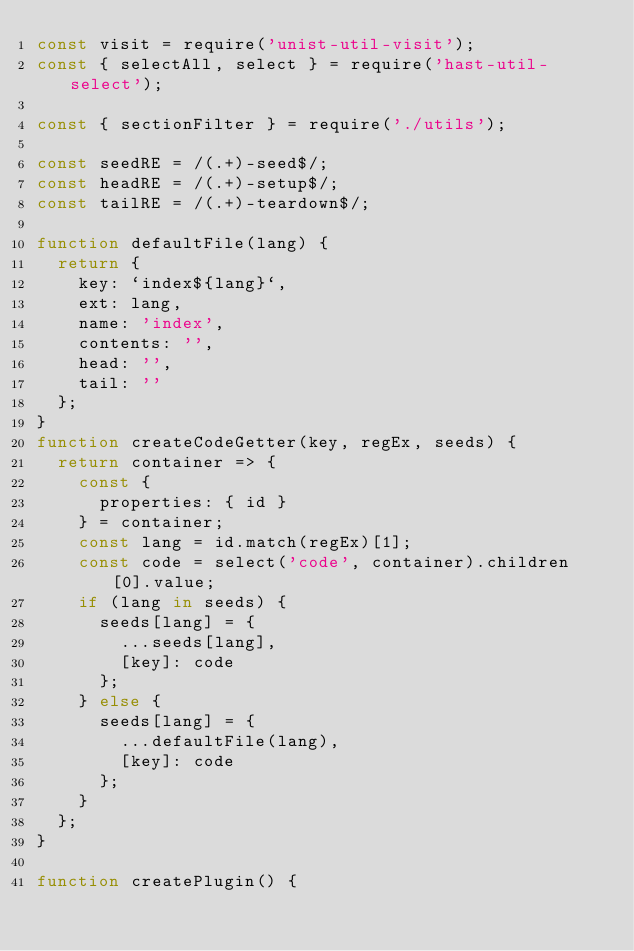<code> <loc_0><loc_0><loc_500><loc_500><_JavaScript_>const visit = require('unist-util-visit');
const { selectAll, select } = require('hast-util-select');

const { sectionFilter } = require('./utils');

const seedRE = /(.+)-seed$/;
const headRE = /(.+)-setup$/;
const tailRE = /(.+)-teardown$/;

function defaultFile(lang) {
  return {
    key: `index${lang}`,
    ext: lang,
    name: 'index',
    contents: '',
    head: '',
    tail: ''
  };
}
function createCodeGetter(key, regEx, seeds) {
  return container => {
    const {
      properties: { id }
    } = container;
    const lang = id.match(regEx)[1];
    const code = select('code', container).children[0].value;
    if (lang in seeds) {
      seeds[lang] = {
        ...seeds[lang],
        [key]: code
      };
    } else {
      seeds[lang] = {
        ...defaultFile(lang),
        [key]: code
      };
    }
  };
}

function createPlugin() {</code> 